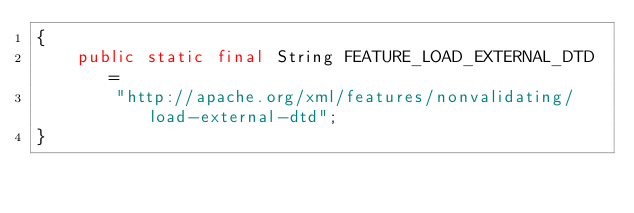Convert code to text. <code><loc_0><loc_0><loc_500><loc_500><_Java_>{
    public static final String FEATURE_LOAD_EXTERNAL_DTD =
        "http://apache.org/xml/features/nonvalidating/load-external-dtd";
}
</code> 